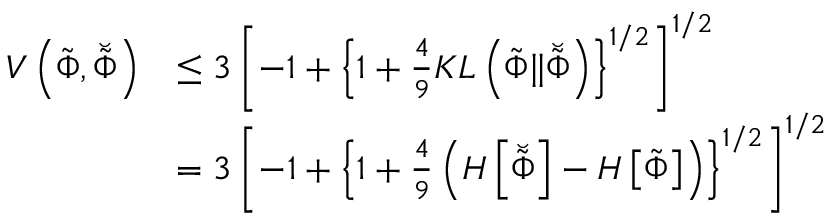<formula> <loc_0><loc_0><loc_500><loc_500>\begin{array} { r l } { V \left ( \tilde { \Phi } , \breve { \tilde { \Phi } } \right ) } & { \leq 3 \left [ - 1 + \left \{ 1 + \frac { 4 } { 9 } K L \left ( \tilde { \Phi } \| \breve { \tilde { \Phi } } \right ) \right \} ^ { 1 / 2 } \right ] ^ { 1 / 2 } } \\ & { = 3 \left [ - 1 + \left \{ 1 + \frac { 4 } { 9 } \left ( H \left [ \breve { \tilde { \Phi } } \right ] - H \left [ \tilde { \Phi } \right ] \right ) \right \} ^ { 1 / 2 } \right ] ^ { 1 / 2 } } \end{array}</formula> 